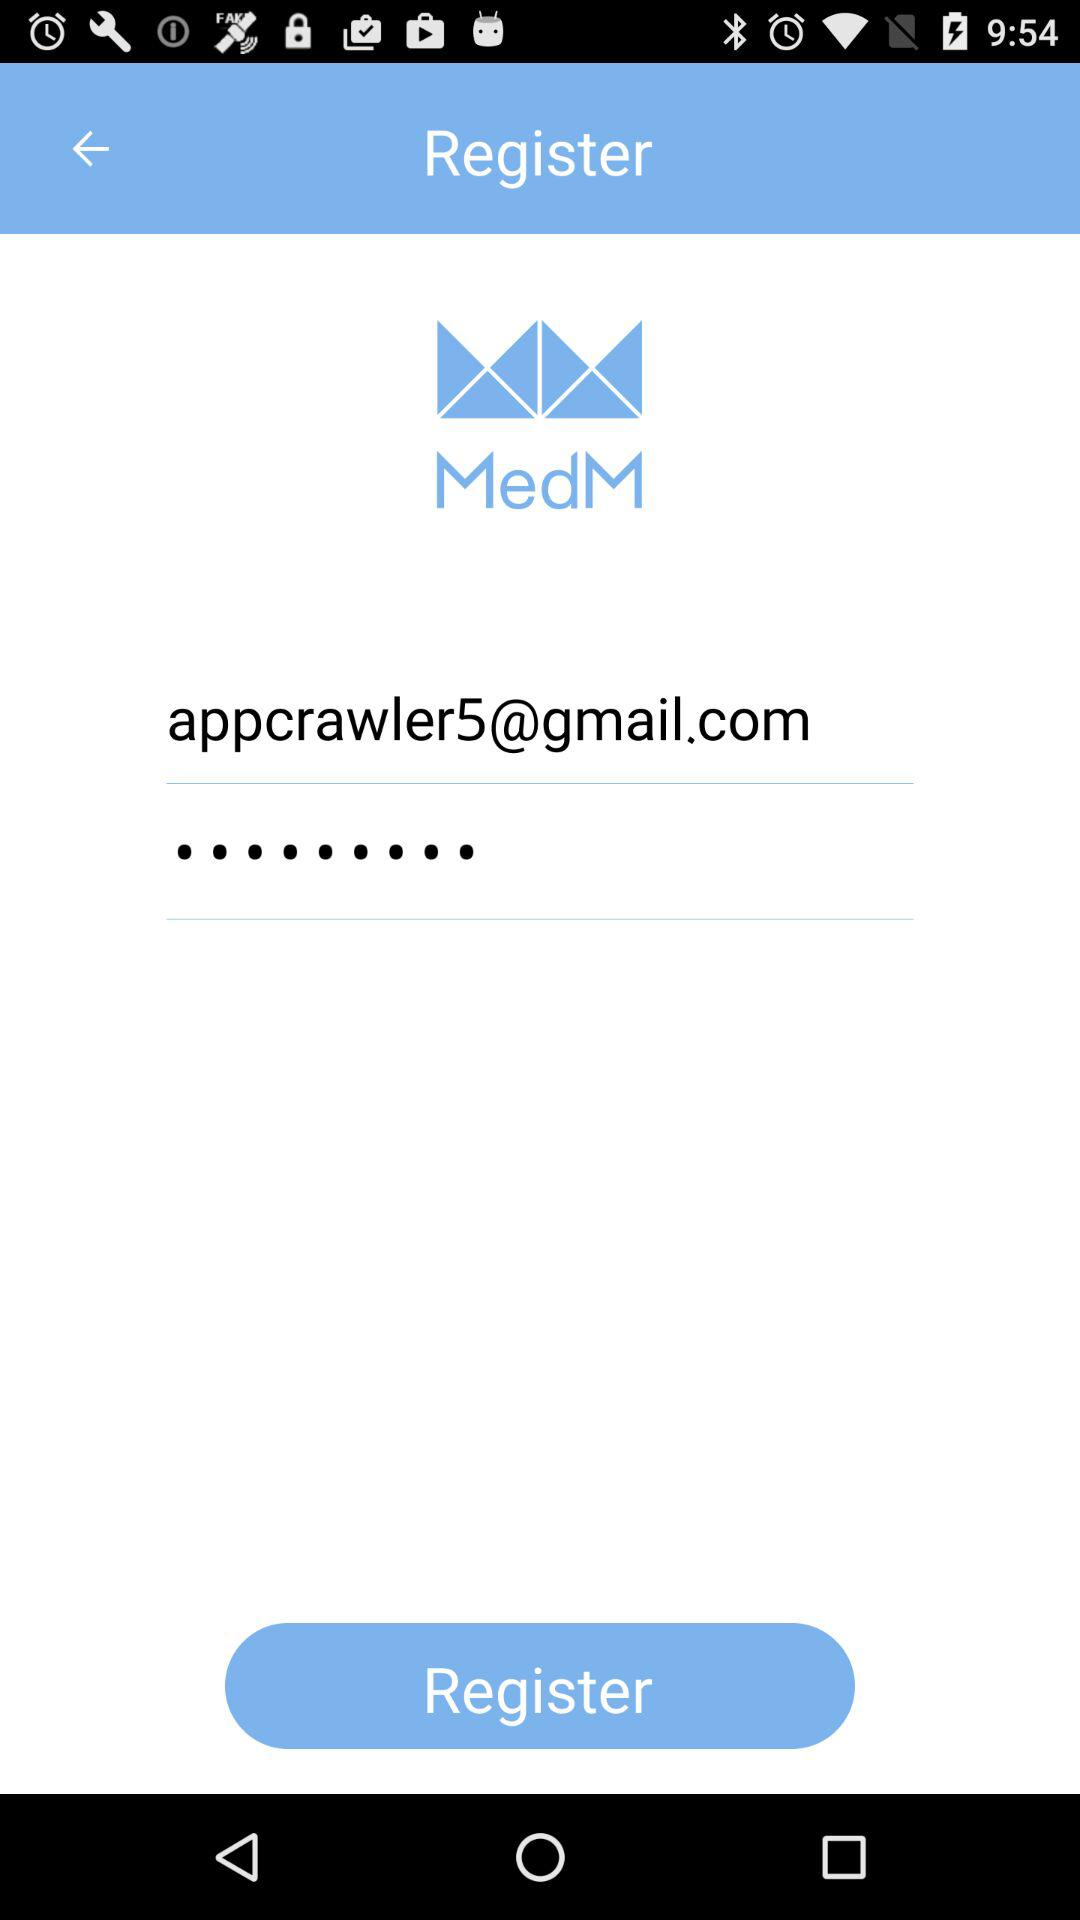What is the email address? The email address is appcrawler5@gmail.com. 